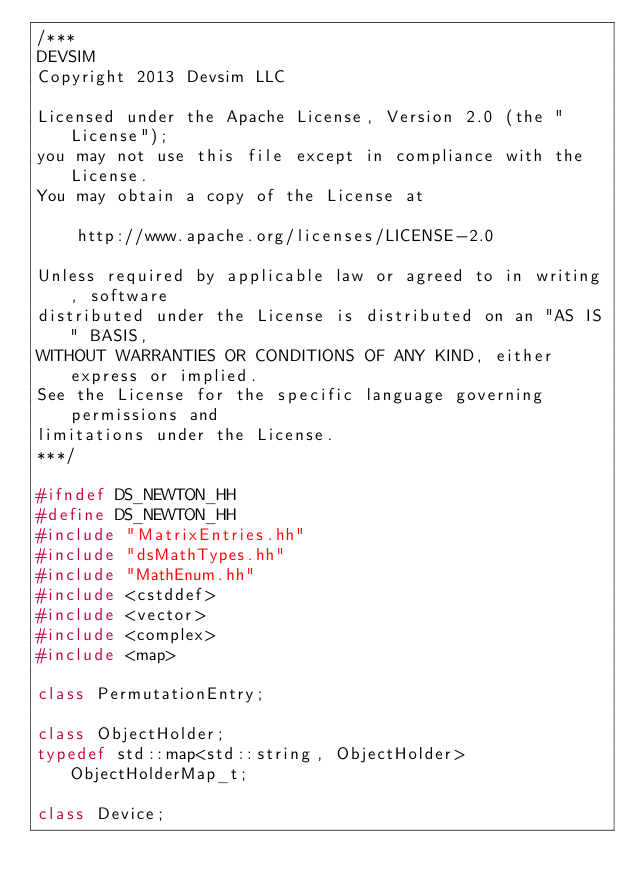Convert code to text. <code><loc_0><loc_0><loc_500><loc_500><_C++_>/***
DEVSIM
Copyright 2013 Devsim LLC

Licensed under the Apache License, Version 2.0 (the "License");
you may not use this file except in compliance with the License.
You may obtain a copy of the License at

    http://www.apache.org/licenses/LICENSE-2.0

Unless required by applicable law or agreed to in writing, software
distributed under the License is distributed on an "AS IS" BASIS,
WITHOUT WARRANTIES OR CONDITIONS OF ANY KIND, either express or implied.
See the License for the specific language governing permissions and
limitations under the License.
***/

#ifndef DS_NEWTON_HH
#define DS_NEWTON_HH
#include "MatrixEntries.hh"
#include "dsMathTypes.hh"
#include "MathEnum.hh"
#include <cstddef>
#include <vector>
#include <complex>
#include <map>

class PermutationEntry;

class ObjectHolder;
typedef std::map<std::string, ObjectHolder> ObjectHolderMap_t;

class Device;</code> 